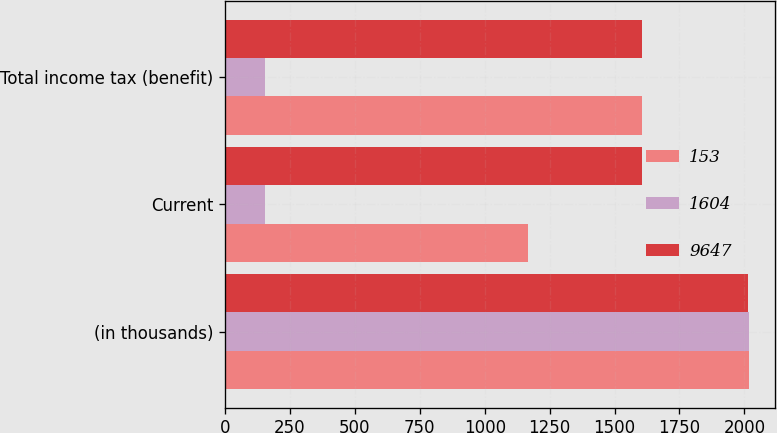<chart> <loc_0><loc_0><loc_500><loc_500><stacked_bar_chart><ecel><fcel>(in thousands)<fcel>Current<fcel>Total income tax (benefit)<nl><fcel>153<fcel>2017<fcel>1168<fcel>1604<nl><fcel>1604<fcel>2016<fcel>153<fcel>153<nl><fcel>9647<fcel>2015<fcel>1604<fcel>1604<nl></chart> 